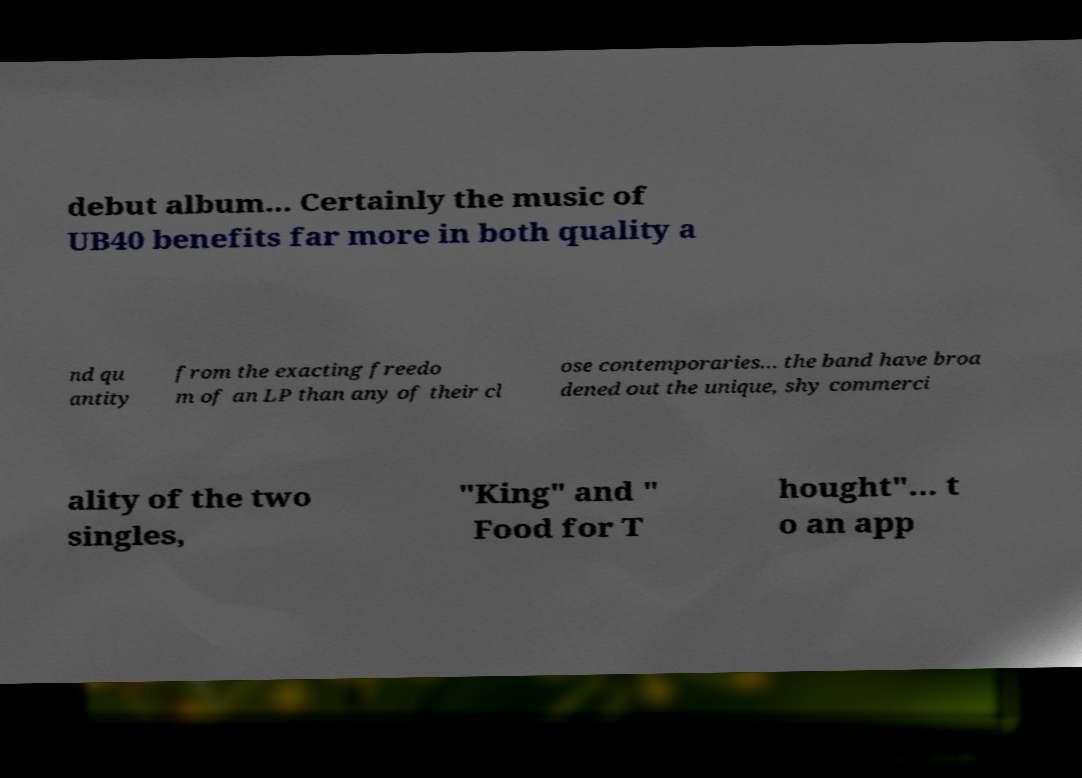Can you read and provide the text displayed in the image?This photo seems to have some interesting text. Can you extract and type it out for me? debut album... Certainly the music of UB40 benefits far more in both quality a nd qu antity from the exacting freedo m of an LP than any of their cl ose contemporaries... the band have broa dened out the unique, shy commerci ality of the two singles, "King" and " Food for T hought"... t o an app 